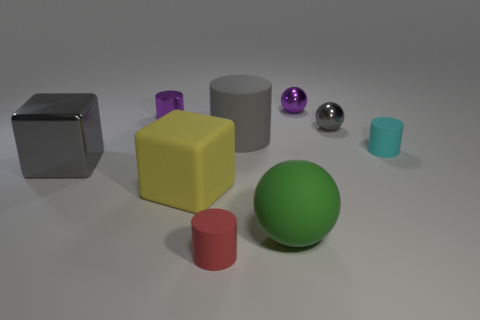Add 1 cyan objects. How many objects exist? 10 Subtract all cubes. How many objects are left? 7 Add 9 yellow matte objects. How many yellow matte objects exist? 10 Subtract 1 green balls. How many objects are left? 8 Subtract all tiny purple metallic things. Subtract all big blue metal balls. How many objects are left? 7 Add 2 big rubber objects. How many big rubber objects are left? 5 